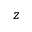Convert formula to latex. <formula><loc_0><loc_0><loc_500><loc_500>z</formula> 